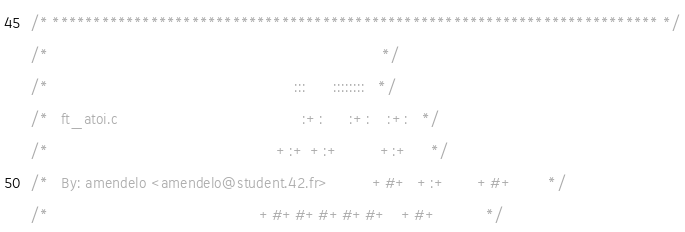Convert code to text. <code><loc_0><loc_0><loc_500><loc_500><_C_>/* ************************************************************************** */
/*                                                                            */
/*                                                        :::      ::::::::   */
/*   ft_atoi.c                                          :+:      :+:    :+:   */
/*                                                    +:+ +:+         +:+     */
/*   By: amendelo <amendelo@student.42.fr>          +#+  +:+       +#+        */
/*                                                +#+#+#+#+#+   +#+           */</code> 